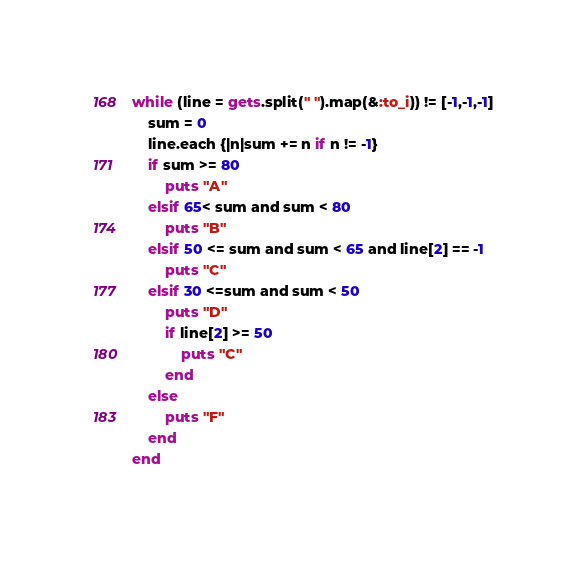Convert code to text. <code><loc_0><loc_0><loc_500><loc_500><_Ruby_>while (line = gets.split(" ").map(&:to_i)) != [-1,-1,-1]
	sum = 0
	line.each {|n|sum += n if n != -1}
	if sum >= 80
		puts "A"
	elsif 65< sum and sum < 80
		puts "B"
	elsif 50 <= sum and sum < 65 and line[2] == -1
		puts "C"
	elsif 30 <=sum and sum < 50  
		puts "D"
		if line[2] >= 50
			puts "C"
		end
	else
		puts "F"
	end
end</code> 